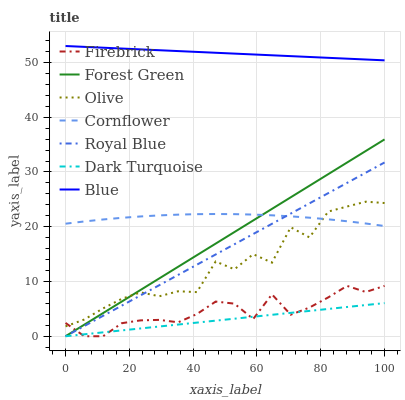Does Dark Turquoise have the minimum area under the curve?
Answer yes or no. Yes. Does Blue have the maximum area under the curve?
Answer yes or no. Yes. Does Cornflower have the minimum area under the curve?
Answer yes or no. No. Does Cornflower have the maximum area under the curve?
Answer yes or no. No. Is Dark Turquoise the smoothest?
Answer yes or no. Yes. Is Olive the roughest?
Answer yes or no. Yes. Is Cornflower the smoothest?
Answer yes or no. No. Is Cornflower the roughest?
Answer yes or no. No. Does Dark Turquoise have the lowest value?
Answer yes or no. Yes. Does Cornflower have the lowest value?
Answer yes or no. No. Does Blue have the highest value?
Answer yes or no. Yes. Does Cornflower have the highest value?
Answer yes or no. No. Is Olive less than Blue?
Answer yes or no. Yes. Is Cornflower greater than Firebrick?
Answer yes or no. Yes. Does Forest Green intersect Cornflower?
Answer yes or no. Yes. Is Forest Green less than Cornflower?
Answer yes or no. No. Is Forest Green greater than Cornflower?
Answer yes or no. No. Does Olive intersect Blue?
Answer yes or no. No. 